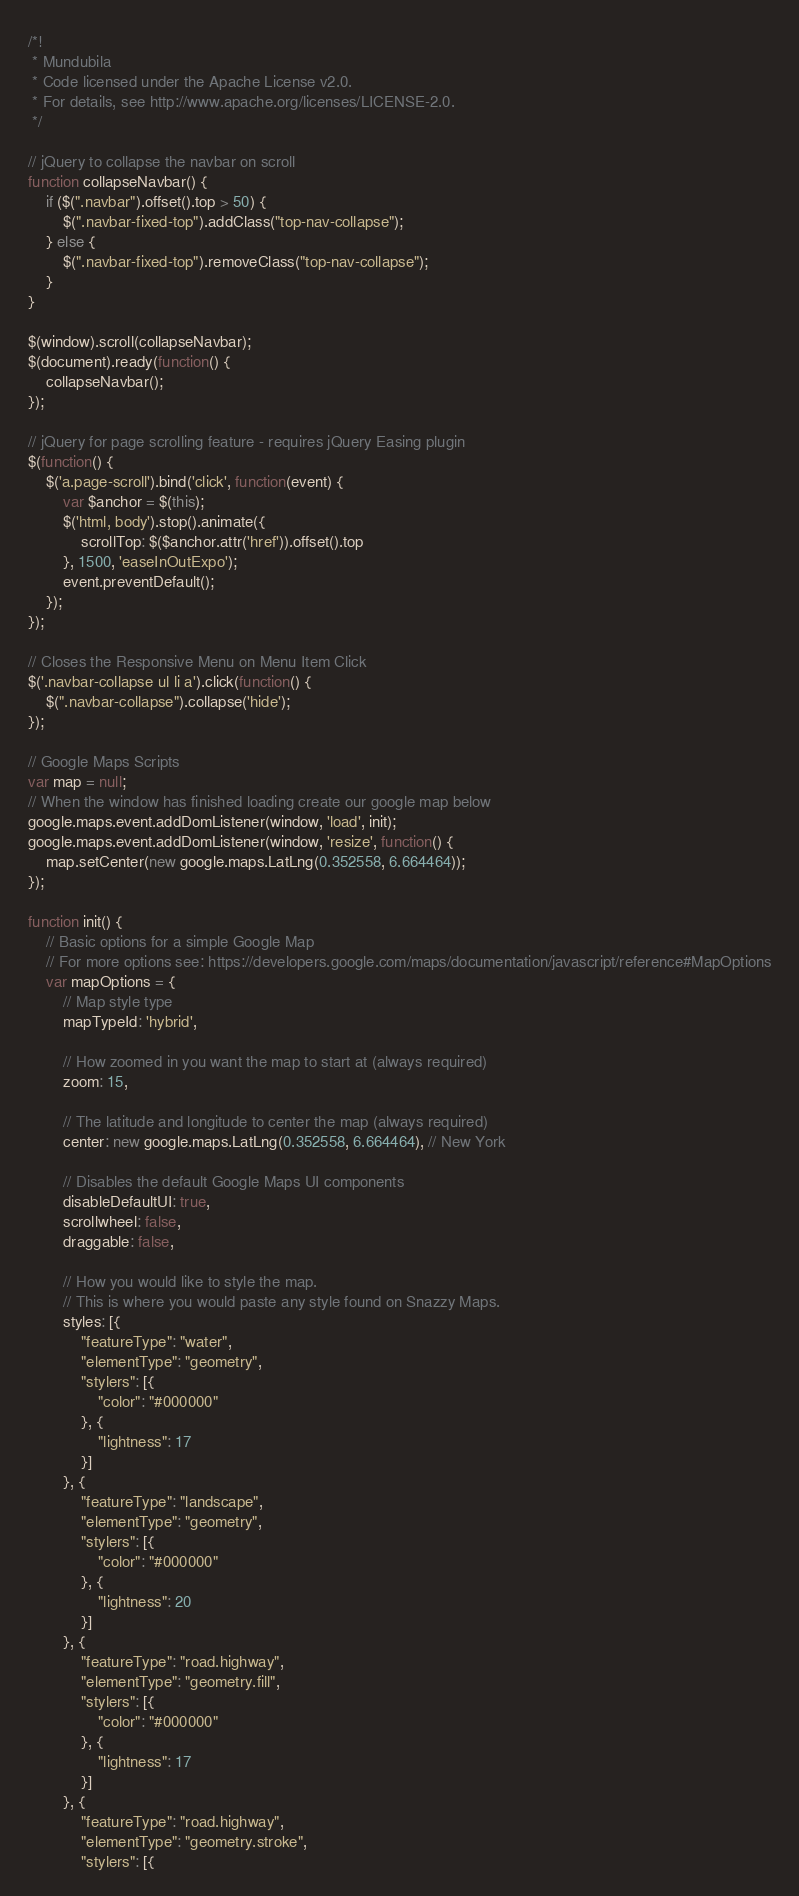<code> <loc_0><loc_0><loc_500><loc_500><_JavaScript_>/*!
 * Mundubila
 * Code licensed under the Apache License v2.0.
 * For details, see http://www.apache.org/licenses/LICENSE-2.0.
 */

// jQuery to collapse the navbar on scroll
function collapseNavbar() {
    if ($(".navbar").offset().top > 50) {
        $(".navbar-fixed-top").addClass("top-nav-collapse");
    } else {
        $(".navbar-fixed-top").removeClass("top-nav-collapse");
    }
}

$(window).scroll(collapseNavbar);
$(document).ready(function() {
    collapseNavbar();
});

// jQuery for page scrolling feature - requires jQuery Easing plugin
$(function() {
    $('a.page-scroll').bind('click', function(event) {
        var $anchor = $(this);
        $('html, body').stop().animate({
            scrollTop: $($anchor.attr('href')).offset().top
        }, 1500, 'easeInOutExpo');
        event.preventDefault();
    });
});

// Closes the Responsive Menu on Menu Item Click
$('.navbar-collapse ul li a').click(function() {
    $(".navbar-collapse").collapse('hide');
});

// Google Maps Scripts
var map = null;
// When the window has finished loading create our google map below
google.maps.event.addDomListener(window, 'load', init);
google.maps.event.addDomListener(window, 'resize', function() {
    map.setCenter(new google.maps.LatLng(0.352558, 6.664464));
});

function init() {
    // Basic options for a simple Google Map
    // For more options see: https://developers.google.com/maps/documentation/javascript/reference#MapOptions
    var mapOptions = {
        // Map style type
        mapTypeId: 'hybrid',

        // How zoomed in you want the map to start at (always required)
        zoom: 15,

        // The latitude and longitude to center the map (always required)
        center: new google.maps.LatLng(0.352558, 6.664464), // New York

        // Disables the default Google Maps UI components
        disableDefaultUI: true,
        scrollwheel: false,
        draggable: false,

        // How you would like to style the map.
        // This is where you would paste any style found on Snazzy Maps.
        styles: [{
            "featureType": "water",
            "elementType": "geometry",
            "stylers": [{
                "color": "#000000"
            }, {
                "lightness": 17
            }]
        }, {
            "featureType": "landscape",
            "elementType": "geometry",
            "stylers": [{
                "color": "#000000"
            }, {
                "lightness": 20
            }]
        }, {
            "featureType": "road.highway",
            "elementType": "geometry.fill",
            "stylers": [{
                "color": "#000000"
            }, {
                "lightness": 17
            }]
        }, {
            "featureType": "road.highway",
            "elementType": "geometry.stroke",
            "stylers": [{</code> 